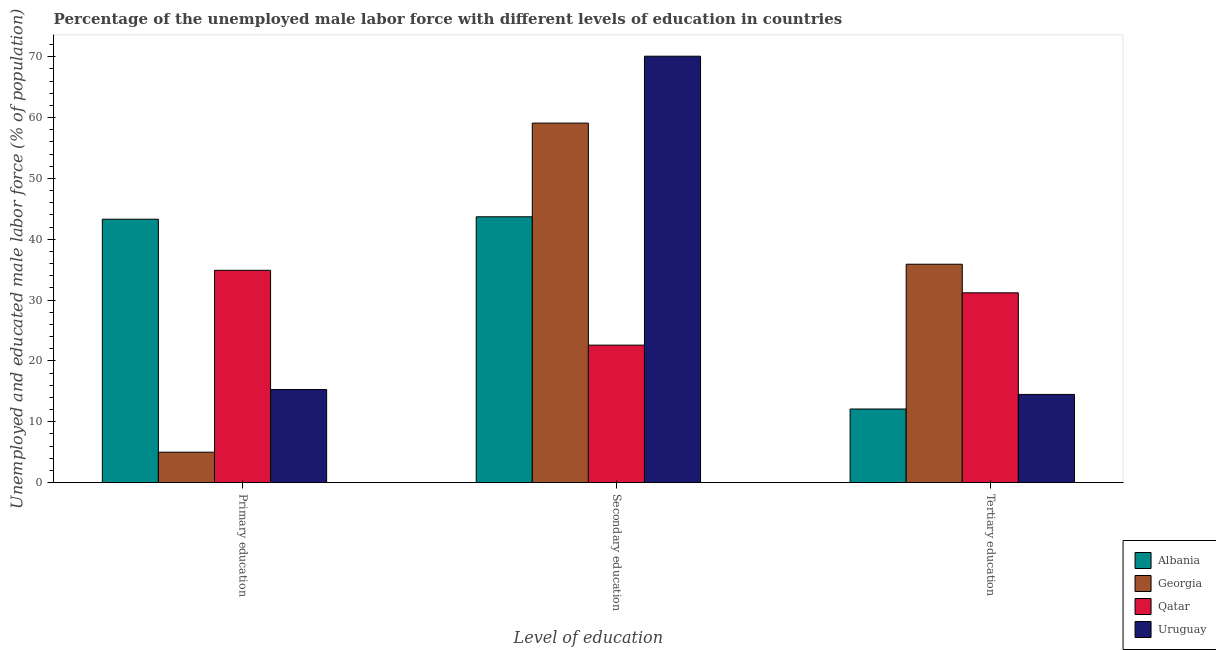How many groups of bars are there?
Ensure brevity in your answer.  3. Are the number of bars on each tick of the X-axis equal?
Provide a succinct answer. Yes. What is the label of the 2nd group of bars from the left?
Ensure brevity in your answer.  Secondary education. What is the percentage of male labor force who received secondary education in Georgia?
Keep it short and to the point. 59.1. Across all countries, what is the maximum percentage of male labor force who received primary education?
Your answer should be very brief. 43.3. Across all countries, what is the minimum percentage of male labor force who received tertiary education?
Offer a terse response. 12.1. In which country was the percentage of male labor force who received tertiary education maximum?
Your answer should be compact. Georgia. In which country was the percentage of male labor force who received secondary education minimum?
Make the answer very short. Qatar. What is the total percentage of male labor force who received secondary education in the graph?
Offer a very short reply. 195.5. What is the difference between the percentage of male labor force who received secondary education in Uruguay and that in Qatar?
Offer a terse response. 47.5. What is the difference between the percentage of male labor force who received primary education in Qatar and the percentage of male labor force who received secondary education in Uruguay?
Ensure brevity in your answer.  -35.2. What is the average percentage of male labor force who received tertiary education per country?
Provide a succinct answer. 23.43. What is the difference between the percentage of male labor force who received secondary education and percentage of male labor force who received primary education in Qatar?
Your answer should be very brief. -12.3. In how many countries, is the percentage of male labor force who received secondary education greater than 62 %?
Provide a succinct answer. 1. What is the ratio of the percentage of male labor force who received tertiary education in Qatar to that in Uruguay?
Ensure brevity in your answer.  2.15. Is the percentage of male labor force who received tertiary education in Albania less than that in Uruguay?
Your response must be concise. Yes. Is the difference between the percentage of male labor force who received primary education in Uruguay and Georgia greater than the difference between the percentage of male labor force who received secondary education in Uruguay and Georgia?
Give a very brief answer. No. What is the difference between the highest and the second highest percentage of male labor force who received primary education?
Make the answer very short. 8.4. What is the difference between the highest and the lowest percentage of male labor force who received primary education?
Provide a succinct answer. 38.3. In how many countries, is the percentage of male labor force who received secondary education greater than the average percentage of male labor force who received secondary education taken over all countries?
Give a very brief answer. 2. Is the sum of the percentage of male labor force who received secondary education in Georgia and Albania greater than the maximum percentage of male labor force who received tertiary education across all countries?
Offer a terse response. Yes. What does the 1st bar from the left in Tertiary education represents?
Ensure brevity in your answer.  Albania. What does the 3rd bar from the right in Secondary education represents?
Make the answer very short. Georgia. How many bars are there?
Your response must be concise. 12. Are all the bars in the graph horizontal?
Provide a short and direct response. No. Does the graph contain any zero values?
Provide a short and direct response. No. Does the graph contain grids?
Provide a short and direct response. No. How many legend labels are there?
Your answer should be very brief. 4. How are the legend labels stacked?
Give a very brief answer. Vertical. What is the title of the graph?
Keep it short and to the point. Percentage of the unemployed male labor force with different levels of education in countries. Does "St. Martin (French part)" appear as one of the legend labels in the graph?
Make the answer very short. No. What is the label or title of the X-axis?
Provide a succinct answer. Level of education. What is the label or title of the Y-axis?
Ensure brevity in your answer.  Unemployed and educated male labor force (% of population). What is the Unemployed and educated male labor force (% of population) of Albania in Primary education?
Your response must be concise. 43.3. What is the Unemployed and educated male labor force (% of population) of Georgia in Primary education?
Keep it short and to the point. 5. What is the Unemployed and educated male labor force (% of population) in Qatar in Primary education?
Your answer should be very brief. 34.9. What is the Unemployed and educated male labor force (% of population) of Uruguay in Primary education?
Your response must be concise. 15.3. What is the Unemployed and educated male labor force (% of population) in Albania in Secondary education?
Your response must be concise. 43.7. What is the Unemployed and educated male labor force (% of population) of Georgia in Secondary education?
Offer a very short reply. 59.1. What is the Unemployed and educated male labor force (% of population) of Qatar in Secondary education?
Make the answer very short. 22.6. What is the Unemployed and educated male labor force (% of population) of Uruguay in Secondary education?
Your answer should be compact. 70.1. What is the Unemployed and educated male labor force (% of population) of Albania in Tertiary education?
Your answer should be compact. 12.1. What is the Unemployed and educated male labor force (% of population) in Georgia in Tertiary education?
Provide a short and direct response. 35.9. What is the Unemployed and educated male labor force (% of population) in Qatar in Tertiary education?
Your answer should be compact. 31.2. What is the Unemployed and educated male labor force (% of population) in Uruguay in Tertiary education?
Provide a succinct answer. 14.5. Across all Level of education, what is the maximum Unemployed and educated male labor force (% of population) of Albania?
Ensure brevity in your answer.  43.7. Across all Level of education, what is the maximum Unemployed and educated male labor force (% of population) of Georgia?
Provide a short and direct response. 59.1. Across all Level of education, what is the maximum Unemployed and educated male labor force (% of population) of Qatar?
Ensure brevity in your answer.  34.9. Across all Level of education, what is the maximum Unemployed and educated male labor force (% of population) of Uruguay?
Offer a very short reply. 70.1. Across all Level of education, what is the minimum Unemployed and educated male labor force (% of population) of Albania?
Your answer should be very brief. 12.1. Across all Level of education, what is the minimum Unemployed and educated male labor force (% of population) in Georgia?
Your answer should be very brief. 5. Across all Level of education, what is the minimum Unemployed and educated male labor force (% of population) of Qatar?
Keep it short and to the point. 22.6. What is the total Unemployed and educated male labor force (% of population) of Albania in the graph?
Your answer should be very brief. 99.1. What is the total Unemployed and educated male labor force (% of population) of Georgia in the graph?
Make the answer very short. 100. What is the total Unemployed and educated male labor force (% of population) of Qatar in the graph?
Offer a terse response. 88.7. What is the total Unemployed and educated male labor force (% of population) in Uruguay in the graph?
Provide a short and direct response. 99.9. What is the difference between the Unemployed and educated male labor force (% of population) of Georgia in Primary education and that in Secondary education?
Your answer should be compact. -54.1. What is the difference between the Unemployed and educated male labor force (% of population) in Qatar in Primary education and that in Secondary education?
Provide a short and direct response. 12.3. What is the difference between the Unemployed and educated male labor force (% of population) of Uruguay in Primary education and that in Secondary education?
Provide a short and direct response. -54.8. What is the difference between the Unemployed and educated male labor force (% of population) of Albania in Primary education and that in Tertiary education?
Your response must be concise. 31.2. What is the difference between the Unemployed and educated male labor force (% of population) in Georgia in Primary education and that in Tertiary education?
Provide a succinct answer. -30.9. What is the difference between the Unemployed and educated male labor force (% of population) of Uruguay in Primary education and that in Tertiary education?
Give a very brief answer. 0.8. What is the difference between the Unemployed and educated male labor force (% of population) in Albania in Secondary education and that in Tertiary education?
Offer a very short reply. 31.6. What is the difference between the Unemployed and educated male labor force (% of population) of Georgia in Secondary education and that in Tertiary education?
Your answer should be compact. 23.2. What is the difference between the Unemployed and educated male labor force (% of population) of Uruguay in Secondary education and that in Tertiary education?
Provide a succinct answer. 55.6. What is the difference between the Unemployed and educated male labor force (% of population) in Albania in Primary education and the Unemployed and educated male labor force (% of population) in Georgia in Secondary education?
Provide a short and direct response. -15.8. What is the difference between the Unemployed and educated male labor force (% of population) of Albania in Primary education and the Unemployed and educated male labor force (% of population) of Qatar in Secondary education?
Your answer should be compact. 20.7. What is the difference between the Unemployed and educated male labor force (% of population) of Albania in Primary education and the Unemployed and educated male labor force (% of population) of Uruguay in Secondary education?
Your response must be concise. -26.8. What is the difference between the Unemployed and educated male labor force (% of population) of Georgia in Primary education and the Unemployed and educated male labor force (% of population) of Qatar in Secondary education?
Provide a short and direct response. -17.6. What is the difference between the Unemployed and educated male labor force (% of population) of Georgia in Primary education and the Unemployed and educated male labor force (% of population) of Uruguay in Secondary education?
Keep it short and to the point. -65.1. What is the difference between the Unemployed and educated male labor force (% of population) of Qatar in Primary education and the Unemployed and educated male labor force (% of population) of Uruguay in Secondary education?
Offer a very short reply. -35.2. What is the difference between the Unemployed and educated male labor force (% of population) in Albania in Primary education and the Unemployed and educated male labor force (% of population) in Uruguay in Tertiary education?
Give a very brief answer. 28.8. What is the difference between the Unemployed and educated male labor force (% of population) in Georgia in Primary education and the Unemployed and educated male labor force (% of population) in Qatar in Tertiary education?
Your response must be concise. -26.2. What is the difference between the Unemployed and educated male labor force (% of population) in Qatar in Primary education and the Unemployed and educated male labor force (% of population) in Uruguay in Tertiary education?
Ensure brevity in your answer.  20.4. What is the difference between the Unemployed and educated male labor force (% of population) in Albania in Secondary education and the Unemployed and educated male labor force (% of population) in Qatar in Tertiary education?
Provide a short and direct response. 12.5. What is the difference between the Unemployed and educated male labor force (% of population) of Albania in Secondary education and the Unemployed and educated male labor force (% of population) of Uruguay in Tertiary education?
Your answer should be compact. 29.2. What is the difference between the Unemployed and educated male labor force (% of population) of Georgia in Secondary education and the Unemployed and educated male labor force (% of population) of Qatar in Tertiary education?
Your answer should be very brief. 27.9. What is the difference between the Unemployed and educated male labor force (% of population) in Georgia in Secondary education and the Unemployed and educated male labor force (% of population) in Uruguay in Tertiary education?
Ensure brevity in your answer.  44.6. What is the difference between the Unemployed and educated male labor force (% of population) in Qatar in Secondary education and the Unemployed and educated male labor force (% of population) in Uruguay in Tertiary education?
Give a very brief answer. 8.1. What is the average Unemployed and educated male labor force (% of population) in Albania per Level of education?
Ensure brevity in your answer.  33.03. What is the average Unemployed and educated male labor force (% of population) of Georgia per Level of education?
Offer a very short reply. 33.33. What is the average Unemployed and educated male labor force (% of population) in Qatar per Level of education?
Make the answer very short. 29.57. What is the average Unemployed and educated male labor force (% of population) of Uruguay per Level of education?
Your answer should be compact. 33.3. What is the difference between the Unemployed and educated male labor force (% of population) in Albania and Unemployed and educated male labor force (% of population) in Georgia in Primary education?
Your answer should be very brief. 38.3. What is the difference between the Unemployed and educated male labor force (% of population) in Georgia and Unemployed and educated male labor force (% of population) in Qatar in Primary education?
Provide a short and direct response. -29.9. What is the difference between the Unemployed and educated male labor force (% of population) of Qatar and Unemployed and educated male labor force (% of population) of Uruguay in Primary education?
Keep it short and to the point. 19.6. What is the difference between the Unemployed and educated male labor force (% of population) in Albania and Unemployed and educated male labor force (% of population) in Georgia in Secondary education?
Your answer should be compact. -15.4. What is the difference between the Unemployed and educated male labor force (% of population) of Albania and Unemployed and educated male labor force (% of population) of Qatar in Secondary education?
Make the answer very short. 21.1. What is the difference between the Unemployed and educated male labor force (% of population) of Albania and Unemployed and educated male labor force (% of population) of Uruguay in Secondary education?
Ensure brevity in your answer.  -26.4. What is the difference between the Unemployed and educated male labor force (% of population) of Georgia and Unemployed and educated male labor force (% of population) of Qatar in Secondary education?
Keep it short and to the point. 36.5. What is the difference between the Unemployed and educated male labor force (% of population) in Qatar and Unemployed and educated male labor force (% of population) in Uruguay in Secondary education?
Your response must be concise. -47.5. What is the difference between the Unemployed and educated male labor force (% of population) of Albania and Unemployed and educated male labor force (% of population) of Georgia in Tertiary education?
Your response must be concise. -23.8. What is the difference between the Unemployed and educated male labor force (% of population) in Albania and Unemployed and educated male labor force (% of population) in Qatar in Tertiary education?
Provide a succinct answer. -19.1. What is the difference between the Unemployed and educated male labor force (% of population) in Albania and Unemployed and educated male labor force (% of population) in Uruguay in Tertiary education?
Offer a terse response. -2.4. What is the difference between the Unemployed and educated male labor force (% of population) of Georgia and Unemployed and educated male labor force (% of population) of Qatar in Tertiary education?
Ensure brevity in your answer.  4.7. What is the difference between the Unemployed and educated male labor force (% of population) in Georgia and Unemployed and educated male labor force (% of population) in Uruguay in Tertiary education?
Your answer should be very brief. 21.4. What is the difference between the Unemployed and educated male labor force (% of population) in Qatar and Unemployed and educated male labor force (% of population) in Uruguay in Tertiary education?
Your answer should be very brief. 16.7. What is the ratio of the Unemployed and educated male labor force (% of population) in Albania in Primary education to that in Secondary education?
Your answer should be very brief. 0.99. What is the ratio of the Unemployed and educated male labor force (% of population) of Georgia in Primary education to that in Secondary education?
Keep it short and to the point. 0.08. What is the ratio of the Unemployed and educated male labor force (% of population) of Qatar in Primary education to that in Secondary education?
Give a very brief answer. 1.54. What is the ratio of the Unemployed and educated male labor force (% of population) in Uruguay in Primary education to that in Secondary education?
Make the answer very short. 0.22. What is the ratio of the Unemployed and educated male labor force (% of population) of Albania in Primary education to that in Tertiary education?
Offer a very short reply. 3.58. What is the ratio of the Unemployed and educated male labor force (% of population) of Georgia in Primary education to that in Tertiary education?
Ensure brevity in your answer.  0.14. What is the ratio of the Unemployed and educated male labor force (% of population) in Qatar in Primary education to that in Tertiary education?
Give a very brief answer. 1.12. What is the ratio of the Unemployed and educated male labor force (% of population) of Uruguay in Primary education to that in Tertiary education?
Provide a succinct answer. 1.06. What is the ratio of the Unemployed and educated male labor force (% of population) of Albania in Secondary education to that in Tertiary education?
Provide a succinct answer. 3.61. What is the ratio of the Unemployed and educated male labor force (% of population) in Georgia in Secondary education to that in Tertiary education?
Give a very brief answer. 1.65. What is the ratio of the Unemployed and educated male labor force (% of population) in Qatar in Secondary education to that in Tertiary education?
Keep it short and to the point. 0.72. What is the ratio of the Unemployed and educated male labor force (% of population) of Uruguay in Secondary education to that in Tertiary education?
Keep it short and to the point. 4.83. What is the difference between the highest and the second highest Unemployed and educated male labor force (% of population) of Georgia?
Your answer should be very brief. 23.2. What is the difference between the highest and the second highest Unemployed and educated male labor force (% of population) in Uruguay?
Give a very brief answer. 54.8. What is the difference between the highest and the lowest Unemployed and educated male labor force (% of population) in Albania?
Your answer should be compact. 31.6. What is the difference between the highest and the lowest Unemployed and educated male labor force (% of population) of Georgia?
Your answer should be very brief. 54.1. What is the difference between the highest and the lowest Unemployed and educated male labor force (% of population) in Uruguay?
Make the answer very short. 55.6. 